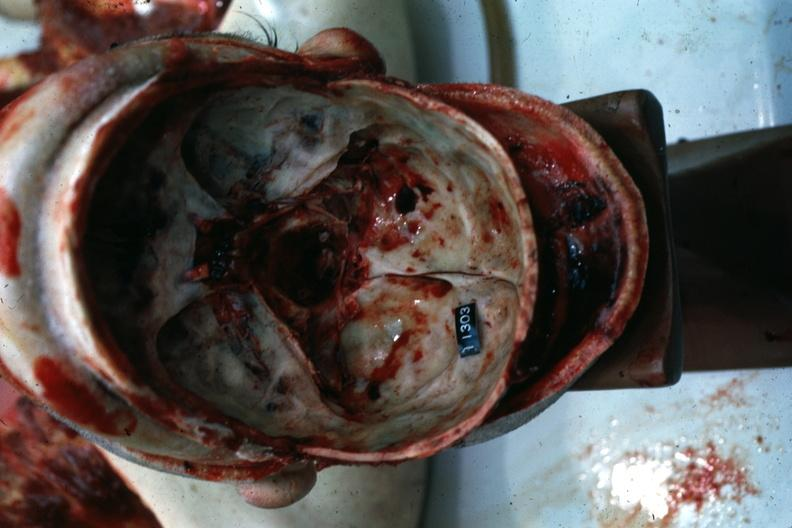what is present?
Answer the question using a single word or phrase. Bone, calvarium 